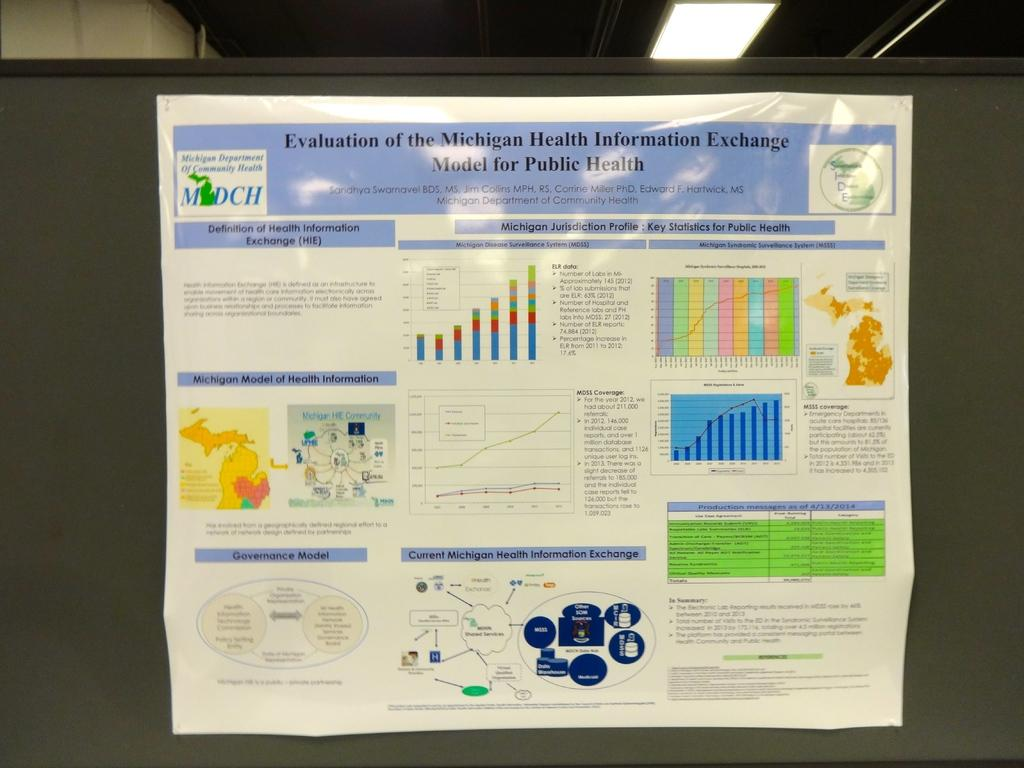<image>
Render a clear and concise summary of the photo. An academic poster talking about the Evaluation of the Michigan Health Information Exchange hangs on a wall. 